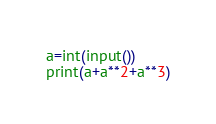<code> <loc_0><loc_0><loc_500><loc_500><_Python_>a=int(input())
print(a+a**2+a**3)
</code> 